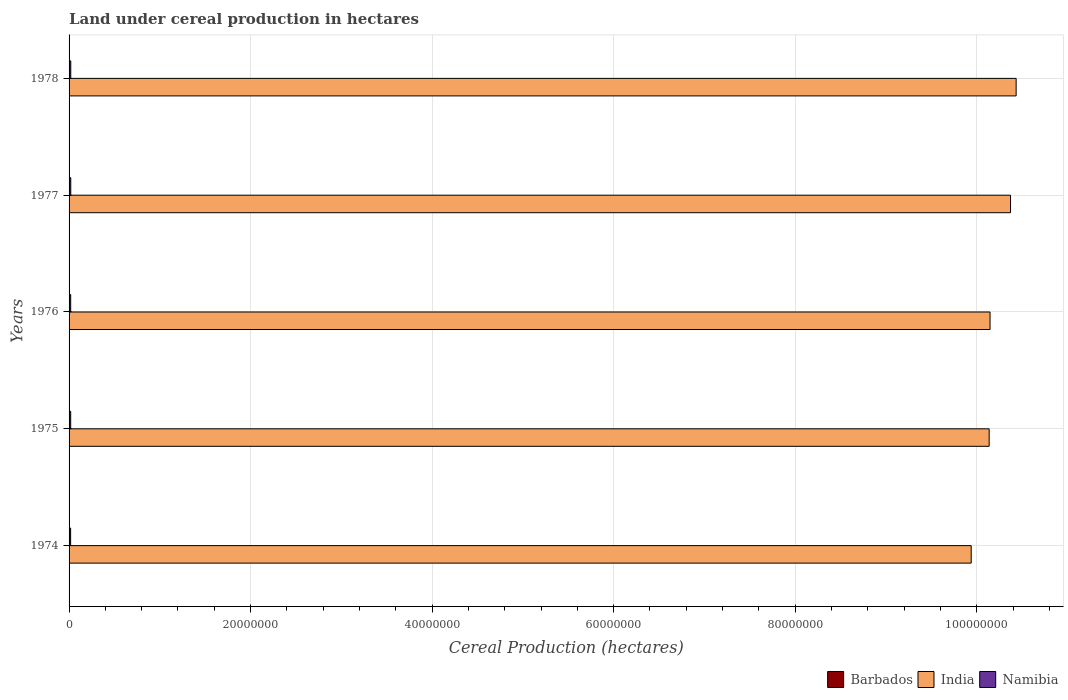How many different coloured bars are there?
Your answer should be very brief. 3. Are the number of bars per tick equal to the number of legend labels?
Your answer should be compact. Yes. How many bars are there on the 3rd tick from the bottom?
Your answer should be compact. 3. What is the label of the 5th group of bars from the top?
Give a very brief answer. 1974. What is the land under cereal production in Namibia in 1977?
Your answer should be very brief. 1.86e+05. Across all years, what is the maximum land under cereal production in India?
Provide a succinct answer. 1.04e+08. Across all years, what is the minimum land under cereal production in India?
Provide a succinct answer. 9.94e+07. In which year was the land under cereal production in Namibia maximum?
Provide a short and direct response. 1978. In which year was the land under cereal production in Namibia minimum?
Make the answer very short. 1974. What is the total land under cereal production in Barbados in the graph?
Your answer should be compact. 3825. What is the difference between the land under cereal production in Namibia in 1974 and that in 1975?
Offer a very short reply. -7000. What is the difference between the land under cereal production in Namibia in 1978 and the land under cereal production in Barbados in 1974?
Make the answer very short. 1.87e+05. What is the average land under cereal production in Barbados per year?
Your answer should be very brief. 765. In the year 1976, what is the difference between the land under cereal production in Barbados and land under cereal production in India?
Give a very brief answer. -1.01e+08. In how many years, is the land under cereal production in Namibia greater than 32000000 hectares?
Keep it short and to the point. 0. What is the ratio of the land under cereal production in Barbados in 1976 to that in 1977?
Your response must be concise. 1. Is the land under cereal production in Barbados in 1974 less than that in 1976?
Ensure brevity in your answer.  No. What is the difference between the highest and the second highest land under cereal production in India?
Your answer should be compact. 6.16e+05. What is the difference between the highest and the lowest land under cereal production in Barbados?
Keep it short and to the point. 0. In how many years, is the land under cereal production in Barbados greater than the average land under cereal production in Barbados taken over all years?
Offer a very short reply. 0. Is the sum of the land under cereal production in India in 1975 and 1977 greater than the maximum land under cereal production in Barbados across all years?
Offer a terse response. Yes. What does the 2nd bar from the top in 1978 represents?
Offer a very short reply. India. What does the 3rd bar from the bottom in 1977 represents?
Offer a very short reply. Namibia. How many bars are there?
Make the answer very short. 15. Are all the bars in the graph horizontal?
Offer a very short reply. Yes. How many years are there in the graph?
Your answer should be compact. 5. What is the difference between two consecutive major ticks on the X-axis?
Provide a short and direct response. 2.00e+07. Are the values on the major ticks of X-axis written in scientific E-notation?
Provide a succinct answer. No. Does the graph contain grids?
Your answer should be very brief. Yes. Where does the legend appear in the graph?
Offer a very short reply. Bottom right. How are the legend labels stacked?
Provide a short and direct response. Horizontal. What is the title of the graph?
Your response must be concise. Land under cereal production in hectares. Does "Jamaica" appear as one of the legend labels in the graph?
Give a very brief answer. No. What is the label or title of the X-axis?
Your answer should be very brief. Cereal Production (hectares). What is the Cereal Production (hectares) of Barbados in 1974?
Offer a terse response. 765. What is the Cereal Production (hectares) in India in 1974?
Your answer should be compact. 9.94e+07. What is the Cereal Production (hectares) in Namibia in 1974?
Provide a short and direct response. 1.70e+05. What is the Cereal Production (hectares) in Barbados in 1975?
Your answer should be compact. 765. What is the Cereal Production (hectares) of India in 1975?
Make the answer very short. 1.01e+08. What is the Cereal Production (hectares) of Namibia in 1975?
Ensure brevity in your answer.  1.77e+05. What is the Cereal Production (hectares) of Barbados in 1976?
Give a very brief answer. 765. What is the Cereal Production (hectares) of India in 1976?
Ensure brevity in your answer.  1.01e+08. What is the Cereal Production (hectares) of Namibia in 1976?
Make the answer very short. 1.78e+05. What is the Cereal Production (hectares) of Barbados in 1977?
Your response must be concise. 765. What is the Cereal Production (hectares) in India in 1977?
Your response must be concise. 1.04e+08. What is the Cereal Production (hectares) in Namibia in 1977?
Give a very brief answer. 1.86e+05. What is the Cereal Production (hectares) in Barbados in 1978?
Give a very brief answer. 765. What is the Cereal Production (hectares) in India in 1978?
Offer a very short reply. 1.04e+08. What is the Cereal Production (hectares) in Namibia in 1978?
Ensure brevity in your answer.  1.87e+05. Across all years, what is the maximum Cereal Production (hectares) in Barbados?
Ensure brevity in your answer.  765. Across all years, what is the maximum Cereal Production (hectares) in India?
Your response must be concise. 1.04e+08. Across all years, what is the maximum Cereal Production (hectares) in Namibia?
Provide a succinct answer. 1.87e+05. Across all years, what is the minimum Cereal Production (hectares) of Barbados?
Your answer should be compact. 765. Across all years, what is the minimum Cereal Production (hectares) in India?
Make the answer very short. 9.94e+07. Across all years, what is the minimum Cereal Production (hectares) of Namibia?
Keep it short and to the point. 1.70e+05. What is the total Cereal Production (hectares) of Barbados in the graph?
Offer a very short reply. 3825. What is the total Cereal Production (hectares) in India in the graph?
Make the answer very short. 5.10e+08. What is the total Cereal Production (hectares) of Namibia in the graph?
Give a very brief answer. 9.00e+05. What is the difference between the Cereal Production (hectares) of Barbados in 1974 and that in 1975?
Give a very brief answer. 0. What is the difference between the Cereal Production (hectares) of India in 1974 and that in 1975?
Provide a short and direct response. -1.98e+06. What is the difference between the Cereal Production (hectares) in Namibia in 1974 and that in 1975?
Your response must be concise. -7000. What is the difference between the Cereal Production (hectares) in Barbados in 1974 and that in 1976?
Provide a short and direct response. 0. What is the difference between the Cereal Production (hectares) in India in 1974 and that in 1976?
Provide a short and direct response. -2.08e+06. What is the difference between the Cereal Production (hectares) in Namibia in 1974 and that in 1976?
Give a very brief answer. -8000. What is the difference between the Cereal Production (hectares) of India in 1974 and that in 1977?
Your response must be concise. -4.33e+06. What is the difference between the Cereal Production (hectares) of Namibia in 1974 and that in 1977?
Ensure brevity in your answer.  -1.60e+04. What is the difference between the Cereal Production (hectares) in India in 1974 and that in 1978?
Provide a short and direct response. -4.95e+06. What is the difference between the Cereal Production (hectares) of Namibia in 1974 and that in 1978?
Your answer should be very brief. -1.70e+04. What is the difference between the Cereal Production (hectares) of India in 1975 and that in 1976?
Make the answer very short. -9.82e+04. What is the difference between the Cereal Production (hectares) in Namibia in 1975 and that in 1976?
Offer a very short reply. -1000. What is the difference between the Cereal Production (hectares) in India in 1975 and that in 1977?
Give a very brief answer. -2.36e+06. What is the difference between the Cereal Production (hectares) in Namibia in 1975 and that in 1977?
Give a very brief answer. -9000. What is the difference between the Cereal Production (hectares) in Barbados in 1975 and that in 1978?
Offer a terse response. 0. What is the difference between the Cereal Production (hectares) of India in 1975 and that in 1978?
Your answer should be compact. -2.97e+06. What is the difference between the Cereal Production (hectares) in India in 1976 and that in 1977?
Your response must be concise. -2.26e+06. What is the difference between the Cereal Production (hectares) of Namibia in 1976 and that in 1977?
Give a very brief answer. -8000. What is the difference between the Cereal Production (hectares) in Barbados in 1976 and that in 1978?
Keep it short and to the point. 0. What is the difference between the Cereal Production (hectares) of India in 1976 and that in 1978?
Provide a short and direct response. -2.87e+06. What is the difference between the Cereal Production (hectares) of Namibia in 1976 and that in 1978?
Offer a terse response. -9000. What is the difference between the Cereal Production (hectares) in Barbados in 1977 and that in 1978?
Offer a terse response. 0. What is the difference between the Cereal Production (hectares) in India in 1977 and that in 1978?
Your answer should be compact. -6.16e+05. What is the difference between the Cereal Production (hectares) of Namibia in 1977 and that in 1978?
Keep it short and to the point. -1000. What is the difference between the Cereal Production (hectares) in Barbados in 1974 and the Cereal Production (hectares) in India in 1975?
Make the answer very short. -1.01e+08. What is the difference between the Cereal Production (hectares) in Barbados in 1974 and the Cereal Production (hectares) in Namibia in 1975?
Keep it short and to the point. -1.77e+05. What is the difference between the Cereal Production (hectares) in India in 1974 and the Cereal Production (hectares) in Namibia in 1975?
Offer a very short reply. 9.92e+07. What is the difference between the Cereal Production (hectares) in Barbados in 1974 and the Cereal Production (hectares) in India in 1976?
Your answer should be compact. -1.01e+08. What is the difference between the Cereal Production (hectares) in Barbados in 1974 and the Cereal Production (hectares) in Namibia in 1976?
Offer a terse response. -1.78e+05. What is the difference between the Cereal Production (hectares) in India in 1974 and the Cereal Production (hectares) in Namibia in 1976?
Your response must be concise. 9.92e+07. What is the difference between the Cereal Production (hectares) of Barbados in 1974 and the Cereal Production (hectares) of India in 1977?
Give a very brief answer. -1.04e+08. What is the difference between the Cereal Production (hectares) in Barbados in 1974 and the Cereal Production (hectares) in Namibia in 1977?
Give a very brief answer. -1.86e+05. What is the difference between the Cereal Production (hectares) of India in 1974 and the Cereal Production (hectares) of Namibia in 1977?
Your answer should be very brief. 9.92e+07. What is the difference between the Cereal Production (hectares) of Barbados in 1974 and the Cereal Production (hectares) of India in 1978?
Your answer should be compact. -1.04e+08. What is the difference between the Cereal Production (hectares) of Barbados in 1974 and the Cereal Production (hectares) of Namibia in 1978?
Provide a succinct answer. -1.87e+05. What is the difference between the Cereal Production (hectares) of India in 1974 and the Cereal Production (hectares) of Namibia in 1978?
Provide a succinct answer. 9.92e+07. What is the difference between the Cereal Production (hectares) of Barbados in 1975 and the Cereal Production (hectares) of India in 1976?
Your answer should be compact. -1.01e+08. What is the difference between the Cereal Production (hectares) of Barbados in 1975 and the Cereal Production (hectares) of Namibia in 1976?
Offer a very short reply. -1.78e+05. What is the difference between the Cereal Production (hectares) in India in 1975 and the Cereal Production (hectares) in Namibia in 1976?
Offer a terse response. 1.01e+08. What is the difference between the Cereal Production (hectares) of Barbados in 1975 and the Cereal Production (hectares) of India in 1977?
Your answer should be very brief. -1.04e+08. What is the difference between the Cereal Production (hectares) in Barbados in 1975 and the Cereal Production (hectares) in Namibia in 1977?
Your response must be concise. -1.86e+05. What is the difference between the Cereal Production (hectares) of India in 1975 and the Cereal Production (hectares) of Namibia in 1977?
Ensure brevity in your answer.  1.01e+08. What is the difference between the Cereal Production (hectares) of Barbados in 1975 and the Cereal Production (hectares) of India in 1978?
Your answer should be compact. -1.04e+08. What is the difference between the Cereal Production (hectares) of Barbados in 1975 and the Cereal Production (hectares) of Namibia in 1978?
Ensure brevity in your answer.  -1.87e+05. What is the difference between the Cereal Production (hectares) in India in 1975 and the Cereal Production (hectares) in Namibia in 1978?
Make the answer very short. 1.01e+08. What is the difference between the Cereal Production (hectares) of Barbados in 1976 and the Cereal Production (hectares) of India in 1977?
Make the answer very short. -1.04e+08. What is the difference between the Cereal Production (hectares) in Barbados in 1976 and the Cereal Production (hectares) in Namibia in 1977?
Your response must be concise. -1.86e+05. What is the difference between the Cereal Production (hectares) in India in 1976 and the Cereal Production (hectares) in Namibia in 1977?
Provide a succinct answer. 1.01e+08. What is the difference between the Cereal Production (hectares) of Barbados in 1976 and the Cereal Production (hectares) of India in 1978?
Your response must be concise. -1.04e+08. What is the difference between the Cereal Production (hectares) in Barbados in 1976 and the Cereal Production (hectares) in Namibia in 1978?
Provide a succinct answer. -1.87e+05. What is the difference between the Cereal Production (hectares) of India in 1976 and the Cereal Production (hectares) of Namibia in 1978?
Offer a very short reply. 1.01e+08. What is the difference between the Cereal Production (hectares) in Barbados in 1977 and the Cereal Production (hectares) in India in 1978?
Your answer should be very brief. -1.04e+08. What is the difference between the Cereal Production (hectares) of Barbados in 1977 and the Cereal Production (hectares) of Namibia in 1978?
Make the answer very short. -1.87e+05. What is the difference between the Cereal Production (hectares) in India in 1977 and the Cereal Production (hectares) in Namibia in 1978?
Offer a terse response. 1.04e+08. What is the average Cereal Production (hectares) of Barbados per year?
Keep it short and to the point. 765. What is the average Cereal Production (hectares) in India per year?
Offer a very short reply. 1.02e+08. What is the average Cereal Production (hectares) of Namibia per year?
Make the answer very short. 1.80e+05. In the year 1974, what is the difference between the Cereal Production (hectares) of Barbados and Cereal Production (hectares) of India?
Your answer should be compact. -9.94e+07. In the year 1974, what is the difference between the Cereal Production (hectares) of Barbados and Cereal Production (hectares) of Namibia?
Make the answer very short. -1.70e+05. In the year 1974, what is the difference between the Cereal Production (hectares) in India and Cereal Production (hectares) in Namibia?
Give a very brief answer. 9.92e+07. In the year 1975, what is the difference between the Cereal Production (hectares) of Barbados and Cereal Production (hectares) of India?
Provide a succinct answer. -1.01e+08. In the year 1975, what is the difference between the Cereal Production (hectares) in Barbados and Cereal Production (hectares) in Namibia?
Your answer should be very brief. -1.77e+05. In the year 1975, what is the difference between the Cereal Production (hectares) in India and Cereal Production (hectares) in Namibia?
Keep it short and to the point. 1.01e+08. In the year 1976, what is the difference between the Cereal Production (hectares) of Barbados and Cereal Production (hectares) of India?
Make the answer very short. -1.01e+08. In the year 1976, what is the difference between the Cereal Production (hectares) of Barbados and Cereal Production (hectares) of Namibia?
Offer a very short reply. -1.78e+05. In the year 1976, what is the difference between the Cereal Production (hectares) in India and Cereal Production (hectares) in Namibia?
Keep it short and to the point. 1.01e+08. In the year 1977, what is the difference between the Cereal Production (hectares) of Barbados and Cereal Production (hectares) of India?
Provide a short and direct response. -1.04e+08. In the year 1977, what is the difference between the Cereal Production (hectares) in Barbados and Cereal Production (hectares) in Namibia?
Provide a short and direct response. -1.86e+05. In the year 1977, what is the difference between the Cereal Production (hectares) in India and Cereal Production (hectares) in Namibia?
Keep it short and to the point. 1.04e+08. In the year 1978, what is the difference between the Cereal Production (hectares) of Barbados and Cereal Production (hectares) of India?
Provide a succinct answer. -1.04e+08. In the year 1978, what is the difference between the Cereal Production (hectares) of Barbados and Cereal Production (hectares) of Namibia?
Offer a very short reply. -1.87e+05. In the year 1978, what is the difference between the Cereal Production (hectares) of India and Cereal Production (hectares) of Namibia?
Give a very brief answer. 1.04e+08. What is the ratio of the Cereal Production (hectares) of India in 1974 to that in 1975?
Provide a succinct answer. 0.98. What is the ratio of the Cereal Production (hectares) of Namibia in 1974 to that in 1975?
Your answer should be very brief. 0.96. What is the ratio of the Cereal Production (hectares) of Barbados in 1974 to that in 1976?
Your answer should be very brief. 1. What is the ratio of the Cereal Production (hectares) of India in 1974 to that in 1976?
Your answer should be very brief. 0.98. What is the ratio of the Cereal Production (hectares) in Namibia in 1974 to that in 1976?
Provide a short and direct response. 0.96. What is the ratio of the Cereal Production (hectares) of Barbados in 1974 to that in 1977?
Give a very brief answer. 1. What is the ratio of the Cereal Production (hectares) of India in 1974 to that in 1977?
Your answer should be compact. 0.96. What is the ratio of the Cereal Production (hectares) of Namibia in 1974 to that in 1977?
Your answer should be compact. 0.91. What is the ratio of the Cereal Production (hectares) of India in 1974 to that in 1978?
Give a very brief answer. 0.95. What is the ratio of the Cereal Production (hectares) in Namibia in 1974 to that in 1978?
Your answer should be compact. 0.91. What is the ratio of the Cereal Production (hectares) of Barbados in 1975 to that in 1976?
Your answer should be very brief. 1. What is the ratio of the Cereal Production (hectares) in India in 1975 to that in 1976?
Your answer should be very brief. 1. What is the ratio of the Cereal Production (hectares) of Namibia in 1975 to that in 1976?
Make the answer very short. 0.99. What is the ratio of the Cereal Production (hectares) in India in 1975 to that in 1977?
Make the answer very short. 0.98. What is the ratio of the Cereal Production (hectares) in Namibia in 1975 to that in 1977?
Offer a terse response. 0.95. What is the ratio of the Cereal Production (hectares) in India in 1975 to that in 1978?
Your response must be concise. 0.97. What is the ratio of the Cereal Production (hectares) in Namibia in 1975 to that in 1978?
Make the answer very short. 0.95. What is the ratio of the Cereal Production (hectares) of Barbados in 1976 to that in 1977?
Make the answer very short. 1. What is the ratio of the Cereal Production (hectares) of India in 1976 to that in 1977?
Make the answer very short. 0.98. What is the ratio of the Cereal Production (hectares) in Namibia in 1976 to that in 1977?
Offer a terse response. 0.96. What is the ratio of the Cereal Production (hectares) of India in 1976 to that in 1978?
Make the answer very short. 0.97. What is the ratio of the Cereal Production (hectares) in Barbados in 1977 to that in 1978?
Your answer should be compact. 1. What is the ratio of the Cereal Production (hectares) in India in 1977 to that in 1978?
Your response must be concise. 0.99. What is the ratio of the Cereal Production (hectares) in Namibia in 1977 to that in 1978?
Give a very brief answer. 0.99. What is the difference between the highest and the second highest Cereal Production (hectares) in Barbados?
Ensure brevity in your answer.  0. What is the difference between the highest and the second highest Cereal Production (hectares) in India?
Provide a succinct answer. 6.16e+05. What is the difference between the highest and the lowest Cereal Production (hectares) in India?
Ensure brevity in your answer.  4.95e+06. What is the difference between the highest and the lowest Cereal Production (hectares) of Namibia?
Your response must be concise. 1.70e+04. 